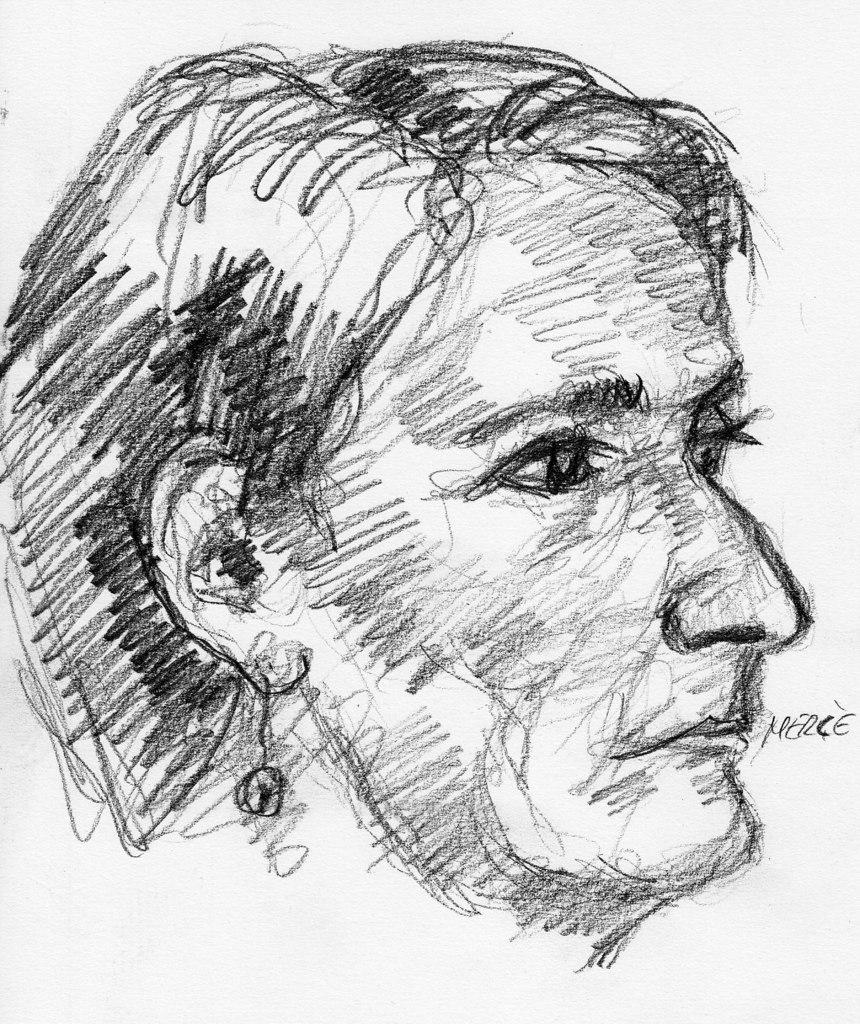What is depicted in the image? There is a drawing of a human face in the image. What color is used for the drawing? The drawing is done using black color. What type of roof is shown in the drawing? A: There is no roof depicted in the drawing; it is a drawing of a human face. 